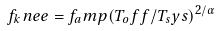<formula> <loc_0><loc_0><loc_500><loc_500>f _ { k } n e e = f _ { a } m p ( T _ { o } f f / T _ { s } y s ) ^ { 2 / \alpha }</formula> 